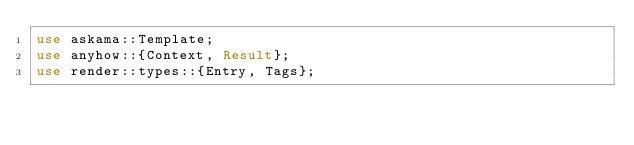<code> <loc_0><loc_0><loc_500><loc_500><_Rust_>use askama::Template;
use anyhow::{Context, Result};
use render::types::{Entry, Tags};</code> 